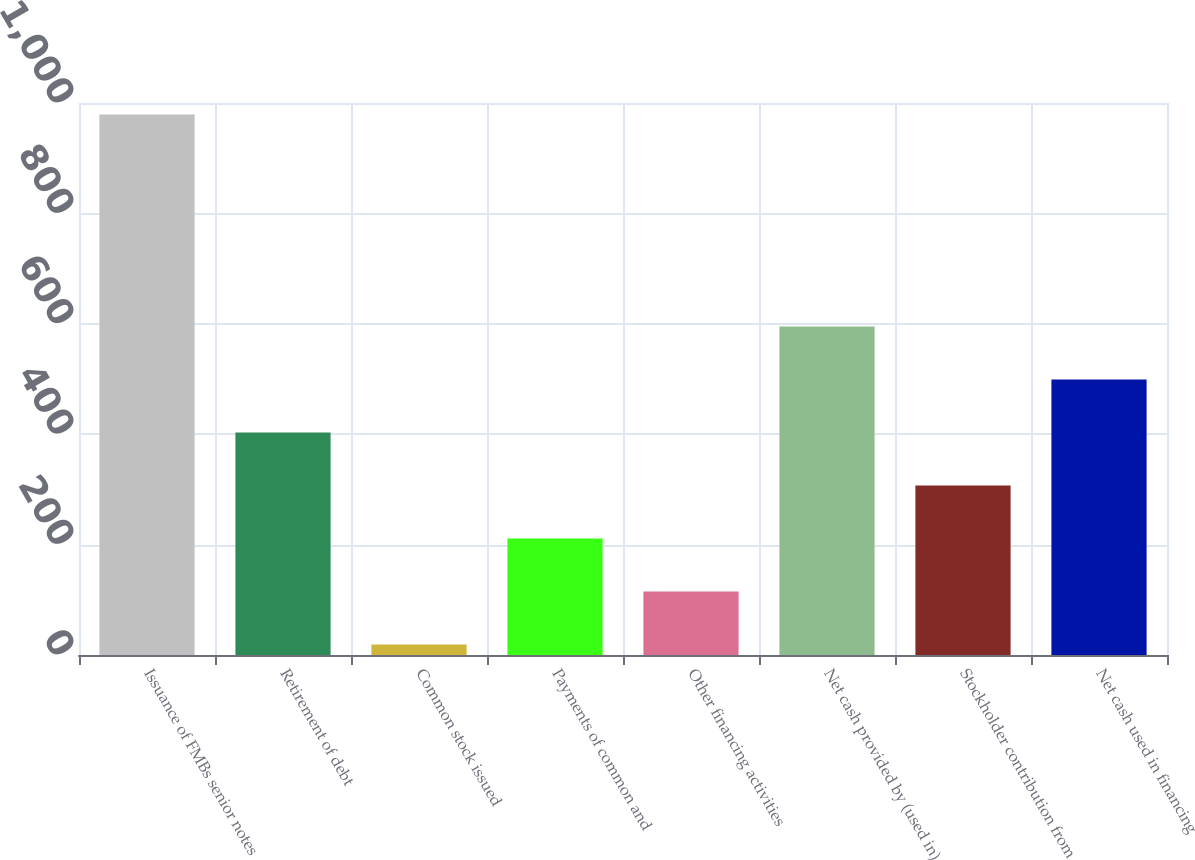Convert chart. <chart><loc_0><loc_0><loc_500><loc_500><bar_chart><fcel>Issuance of FMBs senior notes<fcel>Retirement of debt<fcel>Common stock issued<fcel>Payments of common and<fcel>Other financing activities<fcel>Net cash provided by (used in)<fcel>Stockholder contribution from<fcel>Net cash used in financing<nl><fcel>979<fcel>403<fcel>19<fcel>211<fcel>115<fcel>595<fcel>307<fcel>499<nl></chart> 